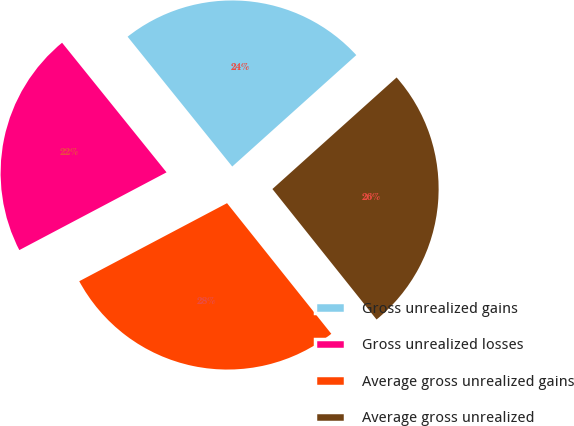<chart> <loc_0><loc_0><loc_500><loc_500><pie_chart><fcel>Gross unrealized gains<fcel>Gross unrealized losses<fcel>Average gross unrealized gains<fcel>Average gross unrealized<nl><fcel>24.15%<fcel>21.94%<fcel>27.99%<fcel>25.93%<nl></chart> 